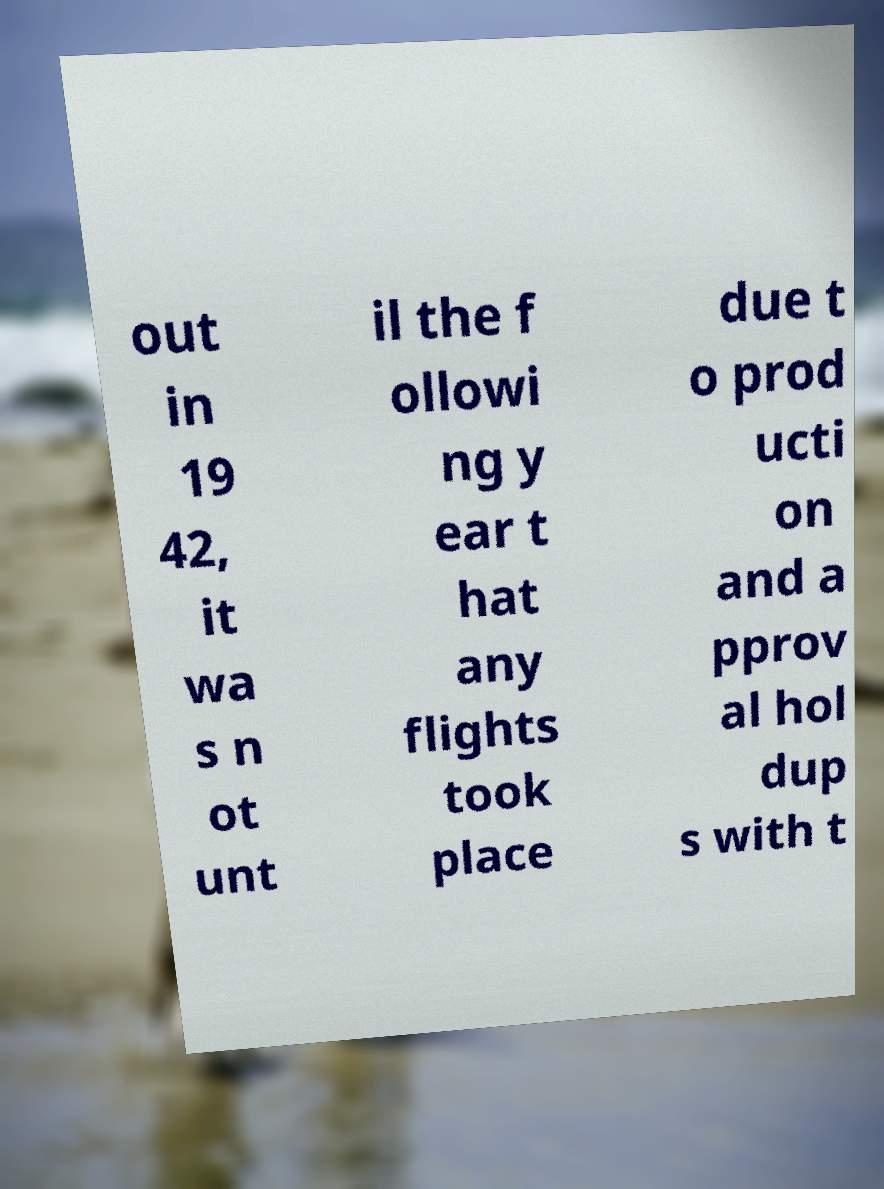Could you assist in decoding the text presented in this image and type it out clearly? out in 19 42, it wa s n ot unt il the f ollowi ng y ear t hat any flights took place due t o prod ucti on and a pprov al hol dup s with t 